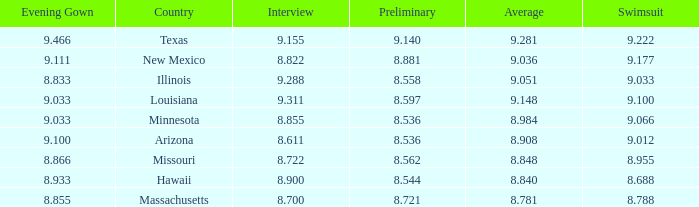What was the average score for the country with the evening gown score of 9.100? 1.0. Parse the table in full. {'header': ['Evening Gown', 'Country', 'Interview', 'Preliminary', 'Average', 'Swimsuit'], 'rows': [['9.466', 'Texas', '9.155', '9.140', '9.281', '9.222'], ['9.111', 'New Mexico', '8.822', '8.881', '9.036', '9.177'], ['8.833', 'Illinois', '9.288', '8.558', '9.051', '9.033'], ['9.033', 'Louisiana', '9.311', '8.597', '9.148', '9.100'], ['9.033', 'Minnesota', '8.855', '8.536', '8.984', '9.066'], ['9.100', 'Arizona', '8.611', '8.536', '8.908', '9.012'], ['8.866', 'Missouri', '8.722', '8.562', '8.848', '8.955'], ['8.933', 'Hawaii', '8.900', '8.544', '8.840', '8.688'], ['8.855', 'Massachusetts', '8.700', '8.721', '8.781', '8.788']]} 